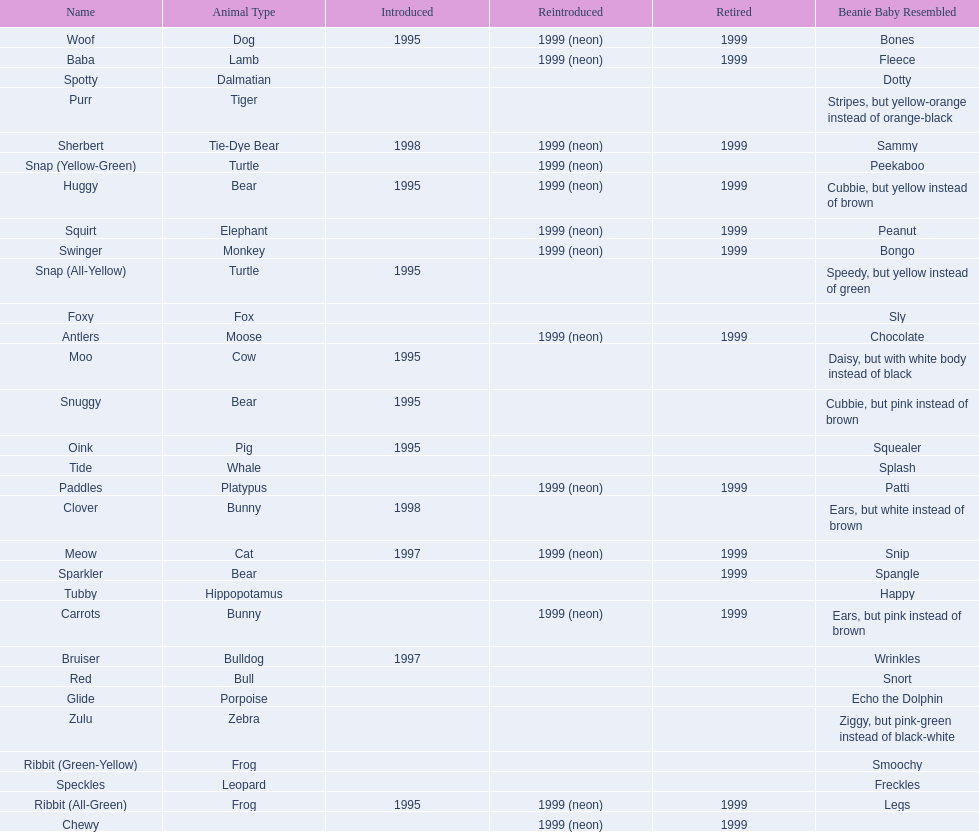Which animal type has the most pillow pals? Bear. 